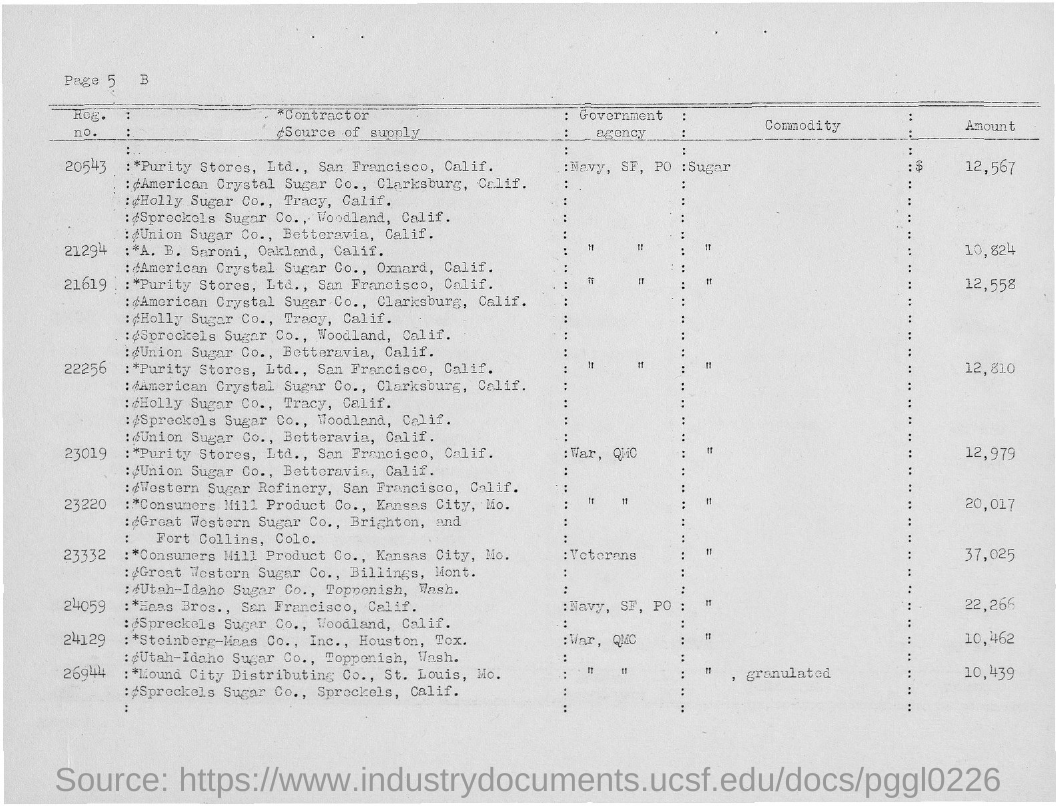Mention a couple of crucial points in this snapshot. The amount for sugar with Registration Number 21294 is 10,824. The amount for sugar with Registration Number 20543 is $12,567. 